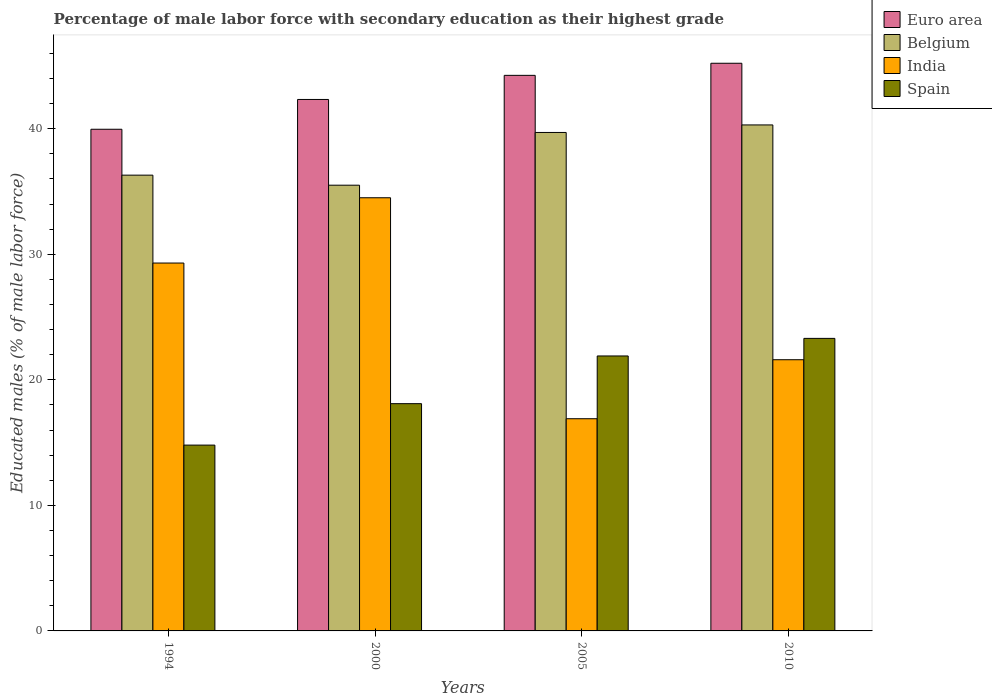Are the number of bars per tick equal to the number of legend labels?
Your response must be concise. Yes. How many bars are there on the 4th tick from the right?
Your response must be concise. 4. In how many cases, is the number of bars for a given year not equal to the number of legend labels?
Keep it short and to the point. 0. What is the percentage of male labor force with secondary education in India in 2010?
Provide a succinct answer. 21.6. Across all years, what is the maximum percentage of male labor force with secondary education in Euro area?
Offer a terse response. 45.21. Across all years, what is the minimum percentage of male labor force with secondary education in India?
Give a very brief answer. 16.9. In which year was the percentage of male labor force with secondary education in Euro area minimum?
Keep it short and to the point. 1994. What is the total percentage of male labor force with secondary education in India in the graph?
Make the answer very short. 102.3. What is the difference between the percentage of male labor force with secondary education in Euro area in 2000 and that in 2010?
Provide a short and direct response. -2.88. What is the difference between the percentage of male labor force with secondary education in Spain in 2000 and the percentage of male labor force with secondary education in Euro area in 2010?
Provide a short and direct response. -27.11. What is the average percentage of male labor force with secondary education in Spain per year?
Offer a very short reply. 19.52. In the year 2005, what is the difference between the percentage of male labor force with secondary education in Euro area and percentage of male labor force with secondary education in Spain?
Offer a terse response. 22.35. What is the ratio of the percentage of male labor force with secondary education in Belgium in 2000 to that in 2005?
Keep it short and to the point. 0.89. Is the percentage of male labor force with secondary education in Spain in 2000 less than that in 2010?
Your answer should be compact. Yes. Is the difference between the percentage of male labor force with secondary education in Euro area in 1994 and 2010 greater than the difference between the percentage of male labor force with secondary education in Spain in 1994 and 2010?
Your response must be concise. Yes. What is the difference between the highest and the second highest percentage of male labor force with secondary education in Belgium?
Make the answer very short. 0.6. What is the difference between the highest and the lowest percentage of male labor force with secondary education in Belgium?
Your response must be concise. 4.8. Is the sum of the percentage of male labor force with secondary education in India in 1994 and 2000 greater than the maximum percentage of male labor force with secondary education in Spain across all years?
Make the answer very short. Yes. Is it the case that in every year, the sum of the percentage of male labor force with secondary education in India and percentage of male labor force with secondary education in Spain is greater than the sum of percentage of male labor force with secondary education in Belgium and percentage of male labor force with secondary education in Euro area?
Make the answer very short. Yes. What does the 2nd bar from the left in 2005 represents?
Your answer should be very brief. Belgium. What does the 1st bar from the right in 2010 represents?
Your response must be concise. Spain. Is it the case that in every year, the sum of the percentage of male labor force with secondary education in India and percentage of male labor force with secondary education in Euro area is greater than the percentage of male labor force with secondary education in Belgium?
Make the answer very short. Yes. Are the values on the major ticks of Y-axis written in scientific E-notation?
Give a very brief answer. No. What is the title of the graph?
Ensure brevity in your answer.  Percentage of male labor force with secondary education as their highest grade. Does "Singapore" appear as one of the legend labels in the graph?
Make the answer very short. No. What is the label or title of the X-axis?
Make the answer very short. Years. What is the label or title of the Y-axis?
Offer a terse response. Educated males (% of male labor force). What is the Educated males (% of male labor force) in Euro area in 1994?
Offer a very short reply. 39.96. What is the Educated males (% of male labor force) in Belgium in 1994?
Provide a short and direct response. 36.3. What is the Educated males (% of male labor force) of India in 1994?
Offer a terse response. 29.3. What is the Educated males (% of male labor force) in Spain in 1994?
Your response must be concise. 14.8. What is the Educated males (% of male labor force) in Euro area in 2000?
Your answer should be compact. 42.33. What is the Educated males (% of male labor force) of Belgium in 2000?
Offer a very short reply. 35.5. What is the Educated males (% of male labor force) of India in 2000?
Ensure brevity in your answer.  34.5. What is the Educated males (% of male labor force) in Spain in 2000?
Provide a short and direct response. 18.1. What is the Educated males (% of male labor force) in Euro area in 2005?
Your response must be concise. 44.25. What is the Educated males (% of male labor force) in Belgium in 2005?
Provide a succinct answer. 39.7. What is the Educated males (% of male labor force) in India in 2005?
Provide a short and direct response. 16.9. What is the Educated males (% of male labor force) of Spain in 2005?
Your answer should be very brief. 21.9. What is the Educated males (% of male labor force) in Euro area in 2010?
Offer a very short reply. 45.21. What is the Educated males (% of male labor force) in Belgium in 2010?
Keep it short and to the point. 40.3. What is the Educated males (% of male labor force) in India in 2010?
Offer a very short reply. 21.6. What is the Educated males (% of male labor force) in Spain in 2010?
Keep it short and to the point. 23.3. Across all years, what is the maximum Educated males (% of male labor force) of Euro area?
Your response must be concise. 45.21. Across all years, what is the maximum Educated males (% of male labor force) in Belgium?
Provide a succinct answer. 40.3. Across all years, what is the maximum Educated males (% of male labor force) in India?
Your response must be concise. 34.5. Across all years, what is the maximum Educated males (% of male labor force) of Spain?
Provide a succinct answer. 23.3. Across all years, what is the minimum Educated males (% of male labor force) of Euro area?
Give a very brief answer. 39.96. Across all years, what is the minimum Educated males (% of male labor force) of Belgium?
Ensure brevity in your answer.  35.5. Across all years, what is the minimum Educated males (% of male labor force) in India?
Your answer should be very brief. 16.9. Across all years, what is the minimum Educated males (% of male labor force) of Spain?
Offer a very short reply. 14.8. What is the total Educated males (% of male labor force) in Euro area in the graph?
Provide a short and direct response. 171.75. What is the total Educated males (% of male labor force) of Belgium in the graph?
Ensure brevity in your answer.  151.8. What is the total Educated males (% of male labor force) in India in the graph?
Give a very brief answer. 102.3. What is the total Educated males (% of male labor force) of Spain in the graph?
Your response must be concise. 78.1. What is the difference between the Educated males (% of male labor force) in Euro area in 1994 and that in 2000?
Your answer should be very brief. -2.37. What is the difference between the Educated males (% of male labor force) of India in 1994 and that in 2000?
Make the answer very short. -5.2. What is the difference between the Educated males (% of male labor force) of Spain in 1994 and that in 2000?
Offer a terse response. -3.3. What is the difference between the Educated males (% of male labor force) in Euro area in 1994 and that in 2005?
Offer a terse response. -4.29. What is the difference between the Educated males (% of male labor force) in Belgium in 1994 and that in 2005?
Offer a very short reply. -3.4. What is the difference between the Educated males (% of male labor force) of India in 1994 and that in 2005?
Your response must be concise. 12.4. What is the difference between the Educated males (% of male labor force) of Euro area in 1994 and that in 2010?
Keep it short and to the point. -5.26. What is the difference between the Educated males (% of male labor force) of Belgium in 1994 and that in 2010?
Provide a succinct answer. -4. What is the difference between the Educated males (% of male labor force) of India in 1994 and that in 2010?
Your response must be concise. 7.7. What is the difference between the Educated males (% of male labor force) in Spain in 1994 and that in 2010?
Your answer should be compact. -8.5. What is the difference between the Educated males (% of male labor force) of Euro area in 2000 and that in 2005?
Your response must be concise. -1.92. What is the difference between the Educated males (% of male labor force) in Belgium in 2000 and that in 2005?
Your answer should be very brief. -4.2. What is the difference between the Educated males (% of male labor force) in India in 2000 and that in 2005?
Provide a short and direct response. 17.6. What is the difference between the Educated males (% of male labor force) in Euro area in 2000 and that in 2010?
Your answer should be very brief. -2.88. What is the difference between the Educated males (% of male labor force) in India in 2000 and that in 2010?
Give a very brief answer. 12.9. What is the difference between the Educated males (% of male labor force) in Spain in 2000 and that in 2010?
Offer a terse response. -5.2. What is the difference between the Educated males (% of male labor force) in Euro area in 2005 and that in 2010?
Offer a very short reply. -0.96. What is the difference between the Educated males (% of male labor force) of Spain in 2005 and that in 2010?
Your answer should be compact. -1.4. What is the difference between the Educated males (% of male labor force) in Euro area in 1994 and the Educated males (% of male labor force) in Belgium in 2000?
Your response must be concise. 4.46. What is the difference between the Educated males (% of male labor force) of Euro area in 1994 and the Educated males (% of male labor force) of India in 2000?
Your response must be concise. 5.46. What is the difference between the Educated males (% of male labor force) of Euro area in 1994 and the Educated males (% of male labor force) of Spain in 2000?
Your answer should be compact. 21.86. What is the difference between the Educated males (% of male labor force) in Belgium in 1994 and the Educated males (% of male labor force) in India in 2000?
Your response must be concise. 1.8. What is the difference between the Educated males (% of male labor force) in India in 1994 and the Educated males (% of male labor force) in Spain in 2000?
Make the answer very short. 11.2. What is the difference between the Educated males (% of male labor force) in Euro area in 1994 and the Educated males (% of male labor force) in Belgium in 2005?
Your answer should be compact. 0.26. What is the difference between the Educated males (% of male labor force) of Euro area in 1994 and the Educated males (% of male labor force) of India in 2005?
Ensure brevity in your answer.  23.06. What is the difference between the Educated males (% of male labor force) in Euro area in 1994 and the Educated males (% of male labor force) in Spain in 2005?
Your answer should be compact. 18.06. What is the difference between the Educated males (% of male labor force) in Belgium in 1994 and the Educated males (% of male labor force) in India in 2005?
Make the answer very short. 19.4. What is the difference between the Educated males (% of male labor force) in India in 1994 and the Educated males (% of male labor force) in Spain in 2005?
Provide a short and direct response. 7.4. What is the difference between the Educated males (% of male labor force) of Euro area in 1994 and the Educated males (% of male labor force) of Belgium in 2010?
Keep it short and to the point. -0.34. What is the difference between the Educated males (% of male labor force) in Euro area in 1994 and the Educated males (% of male labor force) in India in 2010?
Give a very brief answer. 18.36. What is the difference between the Educated males (% of male labor force) of Euro area in 1994 and the Educated males (% of male labor force) of Spain in 2010?
Give a very brief answer. 16.66. What is the difference between the Educated males (% of male labor force) in India in 1994 and the Educated males (% of male labor force) in Spain in 2010?
Keep it short and to the point. 6. What is the difference between the Educated males (% of male labor force) in Euro area in 2000 and the Educated males (% of male labor force) in Belgium in 2005?
Your answer should be compact. 2.63. What is the difference between the Educated males (% of male labor force) of Euro area in 2000 and the Educated males (% of male labor force) of India in 2005?
Your response must be concise. 25.43. What is the difference between the Educated males (% of male labor force) of Euro area in 2000 and the Educated males (% of male labor force) of Spain in 2005?
Ensure brevity in your answer.  20.43. What is the difference between the Educated males (% of male labor force) of Euro area in 2000 and the Educated males (% of male labor force) of Belgium in 2010?
Make the answer very short. 2.03. What is the difference between the Educated males (% of male labor force) of Euro area in 2000 and the Educated males (% of male labor force) of India in 2010?
Keep it short and to the point. 20.73. What is the difference between the Educated males (% of male labor force) of Euro area in 2000 and the Educated males (% of male labor force) of Spain in 2010?
Your response must be concise. 19.03. What is the difference between the Educated males (% of male labor force) of Belgium in 2000 and the Educated males (% of male labor force) of India in 2010?
Provide a short and direct response. 13.9. What is the difference between the Educated males (% of male labor force) of Belgium in 2000 and the Educated males (% of male labor force) of Spain in 2010?
Ensure brevity in your answer.  12.2. What is the difference between the Educated males (% of male labor force) in India in 2000 and the Educated males (% of male labor force) in Spain in 2010?
Offer a terse response. 11.2. What is the difference between the Educated males (% of male labor force) of Euro area in 2005 and the Educated males (% of male labor force) of Belgium in 2010?
Make the answer very short. 3.95. What is the difference between the Educated males (% of male labor force) in Euro area in 2005 and the Educated males (% of male labor force) in India in 2010?
Give a very brief answer. 22.65. What is the difference between the Educated males (% of male labor force) of Euro area in 2005 and the Educated males (% of male labor force) of Spain in 2010?
Make the answer very short. 20.95. What is the difference between the Educated males (% of male labor force) of India in 2005 and the Educated males (% of male labor force) of Spain in 2010?
Make the answer very short. -6.4. What is the average Educated males (% of male labor force) in Euro area per year?
Offer a very short reply. 42.94. What is the average Educated males (% of male labor force) of Belgium per year?
Your answer should be compact. 37.95. What is the average Educated males (% of male labor force) of India per year?
Offer a terse response. 25.57. What is the average Educated males (% of male labor force) of Spain per year?
Offer a very short reply. 19.52. In the year 1994, what is the difference between the Educated males (% of male labor force) of Euro area and Educated males (% of male labor force) of Belgium?
Give a very brief answer. 3.66. In the year 1994, what is the difference between the Educated males (% of male labor force) in Euro area and Educated males (% of male labor force) in India?
Make the answer very short. 10.66. In the year 1994, what is the difference between the Educated males (% of male labor force) of Euro area and Educated males (% of male labor force) of Spain?
Your answer should be compact. 25.16. In the year 1994, what is the difference between the Educated males (% of male labor force) in Belgium and Educated males (% of male labor force) in Spain?
Your answer should be very brief. 21.5. In the year 2000, what is the difference between the Educated males (% of male labor force) of Euro area and Educated males (% of male labor force) of Belgium?
Your answer should be compact. 6.83. In the year 2000, what is the difference between the Educated males (% of male labor force) of Euro area and Educated males (% of male labor force) of India?
Your answer should be compact. 7.83. In the year 2000, what is the difference between the Educated males (% of male labor force) in Euro area and Educated males (% of male labor force) in Spain?
Your answer should be very brief. 24.23. In the year 2000, what is the difference between the Educated males (% of male labor force) of Belgium and Educated males (% of male labor force) of India?
Provide a succinct answer. 1. In the year 2000, what is the difference between the Educated males (% of male labor force) of Belgium and Educated males (% of male labor force) of Spain?
Ensure brevity in your answer.  17.4. In the year 2005, what is the difference between the Educated males (% of male labor force) of Euro area and Educated males (% of male labor force) of Belgium?
Make the answer very short. 4.55. In the year 2005, what is the difference between the Educated males (% of male labor force) of Euro area and Educated males (% of male labor force) of India?
Your response must be concise. 27.35. In the year 2005, what is the difference between the Educated males (% of male labor force) of Euro area and Educated males (% of male labor force) of Spain?
Provide a short and direct response. 22.35. In the year 2005, what is the difference between the Educated males (% of male labor force) of Belgium and Educated males (% of male labor force) of India?
Provide a short and direct response. 22.8. In the year 2005, what is the difference between the Educated males (% of male labor force) of India and Educated males (% of male labor force) of Spain?
Ensure brevity in your answer.  -5. In the year 2010, what is the difference between the Educated males (% of male labor force) of Euro area and Educated males (% of male labor force) of Belgium?
Give a very brief answer. 4.91. In the year 2010, what is the difference between the Educated males (% of male labor force) in Euro area and Educated males (% of male labor force) in India?
Offer a terse response. 23.61. In the year 2010, what is the difference between the Educated males (% of male labor force) of Euro area and Educated males (% of male labor force) of Spain?
Offer a terse response. 21.91. In the year 2010, what is the difference between the Educated males (% of male labor force) of Belgium and Educated males (% of male labor force) of India?
Provide a short and direct response. 18.7. What is the ratio of the Educated males (% of male labor force) in Euro area in 1994 to that in 2000?
Offer a terse response. 0.94. What is the ratio of the Educated males (% of male labor force) in Belgium in 1994 to that in 2000?
Give a very brief answer. 1.02. What is the ratio of the Educated males (% of male labor force) of India in 1994 to that in 2000?
Your answer should be compact. 0.85. What is the ratio of the Educated males (% of male labor force) of Spain in 1994 to that in 2000?
Ensure brevity in your answer.  0.82. What is the ratio of the Educated males (% of male labor force) in Euro area in 1994 to that in 2005?
Ensure brevity in your answer.  0.9. What is the ratio of the Educated males (% of male labor force) in Belgium in 1994 to that in 2005?
Offer a terse response. 0.91. What is the ratio of the Educated males (% of male labor force) of India in 1994 to that in 2005?
Ensure brevity in your answer.  1.73. What is the ratio of the Educated males (% of male labor force) in Spain in 1994 to that in 2005?
Offer a terse response. 0.68. What is the ratio of the Educated males (% of male labor force) in Euro area in 1994 to that in 2010?
Ensure brevity in your answer.  0.88. What is the ratio of the Educated males (% of male labor force) of Belgium in 1994 to that in 2010?
Provide a succinct answer. 0.9. What is the ratio of the Educated males (% of male labor force) in India in 1994 to that in 2010?
Ensure brevity in your answer.  1.36. What is the ratio of the Educated males (% of male labor force) of Spain in 1994 to that in 2010?
Offer a terse response. 0.64. What is the ratio of the Educated males (% of male labor force) in Euro area in 2000 to that in 2005?
Keep it short and to the point. 0.96. What is the ratio of the Educated males (% of male labor force) in Belgium in 2000 to that in 2005?
Give a very brief answer. 0.89. What is the ratio of the Educated males (% of male labor force) of India in 2000 to that in 2005?
Your answer should be compact. 2.04. What is the ratio of the Educated males (% of male labor force) of Spain in 2000 to that in 2005?
Your answer should be compact. 0.83. What is the ratio of the Educated males (% of male labor force) in Euro area in 2000 to that in 2010?
Your answer should be compact. 0.94. What is the ratio of the Educated males (% of male labor force) in Belgium in 2000 to that in 2010?
Offer a terse response. 0.88. What is the ratio of the Educated males (% of male labor force) in India in 2000 to that in 2010?
Offer a very short reply. 1.6. What is the ratio of the Educated males (% of male labor force) of Spain in 2000 to that in 2010?
Ensure brevity in your answer.  0.78. What is the ratio of the Educated males (% of male labor force) of Euro area in 2005 to that in 2010?
Make the answer very short. 0.98. What is the ratio of the Educated males (% of male labor force) in Belgium in 2005 to that in 2010?
Offer a terse response. 0.99. What is the ratio of the Educated males (% of male labor force) in India in 2005 to that in 2010?
Ensure brevity in your answer.  0.78. What is the ratio of the Educated males (% of male labor force) in Spain in 2005 to that in 2010?
Offer a terse response. 0.94. What is the difference between the highest and the second highest Educated males (% of male labor force) in Euro area?
Offer a terse response. 0.96. What is the difference between the highest and the second highest Educated males (% of male labor force) in Belgium?
Your answer should be very brief. 0.6. What is the difference between the highest and the lowest Educated males (% of male labor force) of Euro area?
Give a very brief answer. 5.26. What is the difference between the highest and the lowest Educated males (% of male labor force) in Belgium?
Ensure brevity in your answer.  4.8. What is the difference between the highest and the lowest Educated males (% of male labor force) in Spain?
Give a very brief answer. 8.5. 